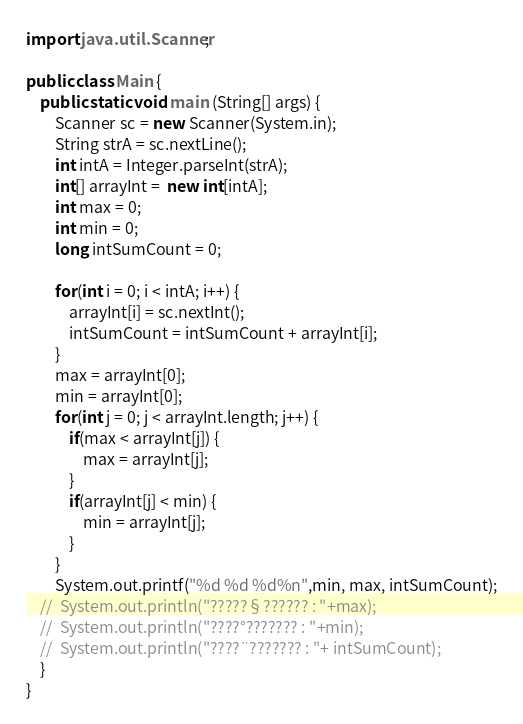Convert code to text. <code><loc_0><loc_0><loc_500><loc_500><_Java_>import java.util.Scanner;

public class Main {
	public static void main (String[] args) {
		Scanner sc = new Scanner(System.in);
		String strA = sc.nextLine();
		int intA = Integer.parseInt(strA);
		int[] arrayInt =  new int[intA];
		int max = 0;
		int min = 0;
		long intSumCount = 0;

		for(int i = 0; i < intA; i++) {
			arrayInt[i] = sc.nextInt();
			intSumCount = intSumCount + arrayInt[i];
		}
		max = arrayInt[0];
		min = arrayInt[0];
		for(int j = 0; j < arrayInt.length; j++) {
			if(max < arrayInt[j]) {
				max = arrayInt[j];
			}
			if(arrayInt[j] < min) {
				min = arrayInt[j];
			}
		}
		System.out.printf("%d %d %d%n",min, max, intSumCount);
	//	System.out.println("?????§?????? : "+max);
	//	System.out.println("????°??????? : "+min);
	//	System.out.println("????¨??????? : "+ intSumCount);
	}
}</code> 